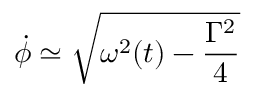<formula> <loc_0><loc_0><loc_500><loc_500>\dot { \phi } \simeq \sqrt { \omega ^ { 2 } ( t ) - \frac { \Gamma ^ { 2 } } { 4 } }</formula> 